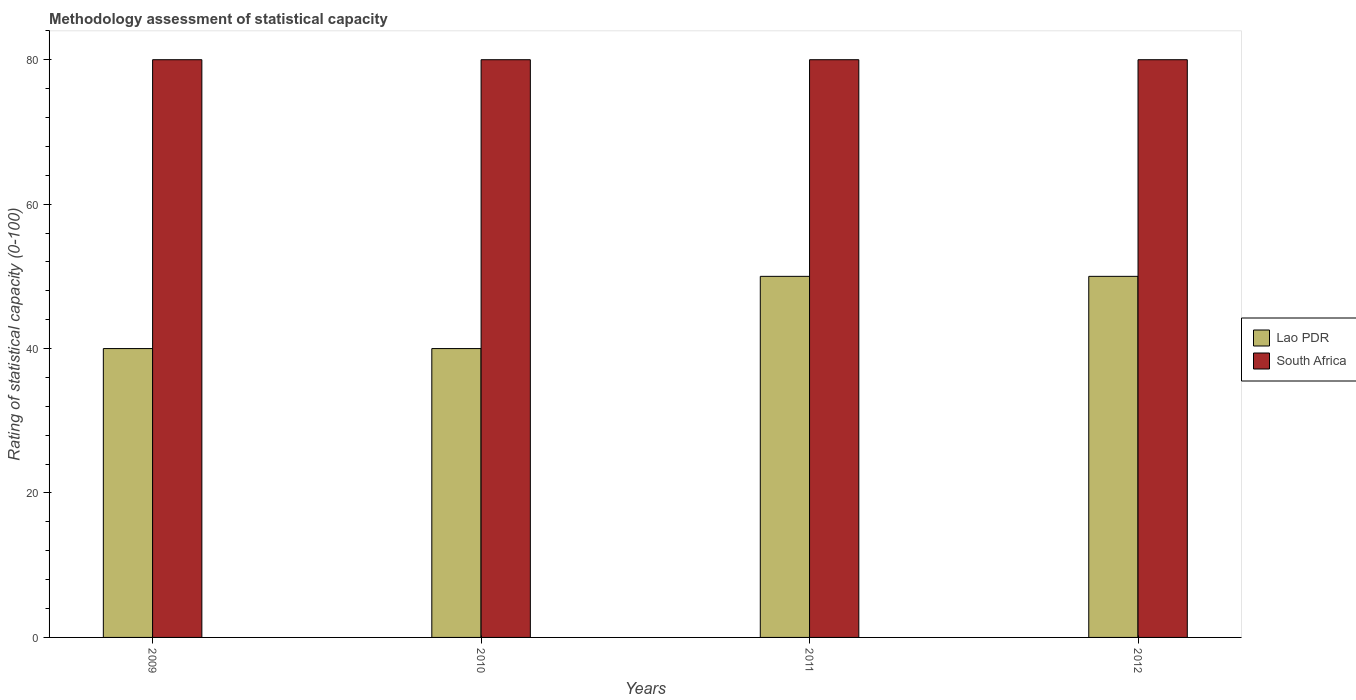How many different coloured bars are there?
Your answer should be very brief. 2. How many groups of bars are there?
Your answer should be very brief. 4. Are the number of bars per tick equal to the number of legend labels?
Give a very brief answer. Yes. Are the number of bars on each tick of the X-axis equal?
Your answer should be very brief. Yes. How many bars are there on the 2nd tick from the left?
Your answer should be very brief. 2. What is the rating of statistical capacity in Lao PDR in 2011?
Give a very brief answer. 50. Across all years, what is the maximum rating of statistical capacity in South Africa?
Make the answer very short. 80. Across all years, what is the minimum rating of statistical capacity in Lao PDR?
Provide a succinct answer. 40. What is the total rating of statistical capacity in South Africa in the graph?
Your answer should be compact. 320. What is the difference between the rating of statistical capacity in South Africa in 2009 and that in 2012?
Your response must be concise. 0. What is the difference between the rating of statistical capacity in Lao PDR in 2011 and the rating of statistical capacity in South Africa in 2010?
Offer a terse response. -30. What is the average rating of statistical capacity in Lao PDR per year?
Provide a short and direct response. 45. In the year 2011, what is the difference between the rating of statistical capacity in South Africa and rating of statistical capacity in Lao PDR?
Ensure brevity in your answer.  30. What is the ratio of the rating of statistical capacity in South Africa in 2009 to that in 2012?
Your answer should be very brief. 1. What is the difference between the highest and the second highest rating of statistical capacity in Lao PDR?
Your answer should be very brief. 0. What is the difference between the highest and the lowest rating of statistical capacity in Lao PDR?
Provide a succinct answer. 10. What does the 1st bar from the left in 2012 represents?
Your answer should be compact. Lao PDR. What does the 2nd bar from the right in 2009 represents?
Make the answer very short. Lao PDR. Are all the bars in the graph horizontal?
Ensure brevity in your answer.  No. How many years are there in the graph?
Offer a terse response. 4. What is the difference between two consecutive major ticks on the Y-axis?
Your response must be concise. 20. Are the values on the major ticks of Y-axis written in scientific E-notation?
Make the answer very short. No. What is the title of the graph?
Provide a succinct answer. Methodology assessment of statistical capacity. Does "Sierra Leone" appear as one of the legend labels in the graph?
Keep it short and to the point. No. What is the label or title of the Y-axis?
Provide a short and direct response. Rating of statistical capacity (0-100). What is the Rating of statistical capacity (0-100) of Lao PDR in 2009?
Give a very brief answer. 40. What is the Rating of statistical capacity (0-100) in South Africa in 2009?
Ensure brevity in your answer.  80. What is the Rating of statistical capacity (0-100) in Lao PDR in 2010?
Provide a succinct answer. 40. What is the Rating of statistical capacity (0-100) of South Africa in 2010?
Keep it short and to the point. 80. What is the Rating of statistical capacity (0-100) of South Africa in 2012?
Offer a very short reply. 80. Across all years, what is the minimum Rating of statistical capacity (0-100) in Lao PDR?
Your response must be concise. 40. What is the total Rating of statistical capacity (0-100) of Lao PDR in the graph?
Ensure brevity in your answer.  180. What is the total Rating of statistical capacity (0-100) in South Africa in the graph?
Your answer should be compact. 320. What is the difference between the Rating of statistical capacity (0-100) in South Africa in 2009 and that in 2010?
Offer a very short reply. 0. What is the difference between the Rating of statistical capacity (0-100) in South Africa in 2009 and that in 2011?
Provide a short and direct response. 0. What is the difference between the Rating of statistical capacity (0-100) in Lao PDR in 2009 and that in 2012?
Your answer should be very brief. -10. What is the difference between the Rating of statistical capacity (0-100) in South Africa in 2010 and that in 2011?
Offer a very short reply. 0. What is the difference between the Rating of statistical capacity (0-100) in South Africa in 2010 and that in 2012?
Offer a terse response. 0. What is the difference between the Rating of statistical capacity (0-100) in South Africa in 2011 and that in 2012?
Provide a succinct answer. 0. What is the difference between the Rating of statistical capacity (0-100) in Lao PDR in 2009 and the Rating of statistical capacity (0-100) in South Africa in 2010?
Offer a very short reply. -40. What is the difference between the Rating of statistical capacity (0-100) in Lao PDR in 2009 and the Rating of statistical capacity (0-100) in South Africa in 2011?
Your answer should be very brief. -40. What is the difference between the Rating of statistical capacity (0-100) of Lao PDR in 2010 and the Rating of statistical capacity (0-100) of South Africa in 2012?
Ensure brevity in your answer.  -40. What is the average Rating of statistical capacity (0-100) of Lao PDR per year?
Give a very brief answer. 45. What is the average Rating of statistical capacity (0-100) in South Africa per year?
Provide a succinct answer. 80. What is the ratio of the Rating of statistical capacity (0-100) in Lao PDR in 2009 to that in 2010?
Make the answer very short. 1. What is the ratio of the Rating of statistical capacity (0-100) in South Africa in 2009 to that in 2010?
Your response must be concise. 1. What is the ratio of the Rating of statistical capacity (0-100) of Lao PDR in 2009 to that in 2011?
Your answer should be very brief. 0.8. What is the ratio of the Rating of statistical capacity (0-100) of South Africa in 2009 to that in 2012?
Your answer should be compact. 1. What is the ratio of the Rating of statistical capacity (0-100) of South Africa in 2011 to that in 2012?
Offer a terse response. 1. What is the difference between the highest and the lowest Rating of statistical capacity (0-100) in Lao PDR?
Offer a terse response. 10. What is the difference between the highest and the lowest Rating of statistical capacity (0-100) in South Africa?
Keep it short and to the point. 0. 